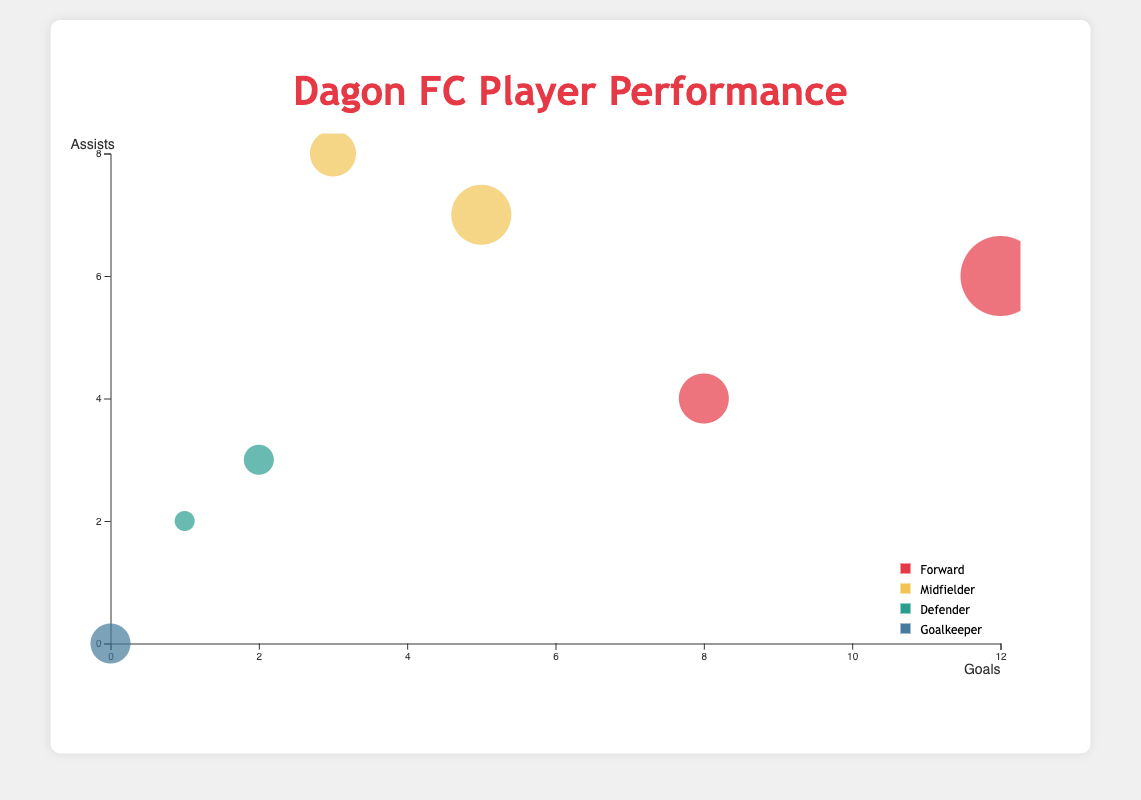What is the title of the figure? The title is the text at the top center of the figure. Here it clearly states "Dagon FC Player Performance".
Answer: Dagon FC Player Performance How many players are displayed in the chart? Count the number of circles in the chart, each representing a player. There are 7 players shown.
Answer: 7 Which position does Kyaw Ko Ko play in and how many goals has he scored? Locate the circle corresponding to Kyaw Ko Ko, check the color legend to find his position, and hover over the circle to see his goals. He is a Forward and has scored 12 goals.
Answer: Forward, 12 Who has the highest Performance Score and what is that score? Look for the largest circle as size represents Performance Score; hovering over it will show details. Kyaw Ko Ko has the highest Performance Score of 95.
Answer: Kyaw Ko Ko, 95 What is the total number of assists made by both Akung Thu and Zaw Min Tun? Find the circles for Aung Thu and Zaw Min Tun, hover for details, and sum their assists (4 + 7 = 11).
Answer: 11 Who is the only player with zero goals, and what position do they play? Locate any circle on the x-axis position of zero goals, hover over the circle to get details. Kyi Lin is the player and he is a Goalkeeper.
Answer: Kyi Lin, Goalkeeper Between forwards and defenders, which group has a player with a higher Performance Score? Compare the Performance Scores of the highest-scoring Forward and Defender groups. Kyaw Ko Ko (95, Forward) vs. David Htan (70, Defender).
Answer: Forward Which midfielder has the most appearances, and how many are they? Look for circles colored as Midfielders, hover over them, and check appearances. Zaw Min Tun has 22 appearances.
Answer: Zaw Min Tun, 22 Do more players have assists in the range of 2-5 or 6-8? Count the number of circles within the specified assists range (5 players have assists 2-5, 2 players have assists 6-8).
Answer: 2-5 How many positions are represented in the chart? Refer to the color legend to count the distinct positions shown. There are four positions: Forward, Midfielder, Defender, and Goalkeeper.
Answer: 4 